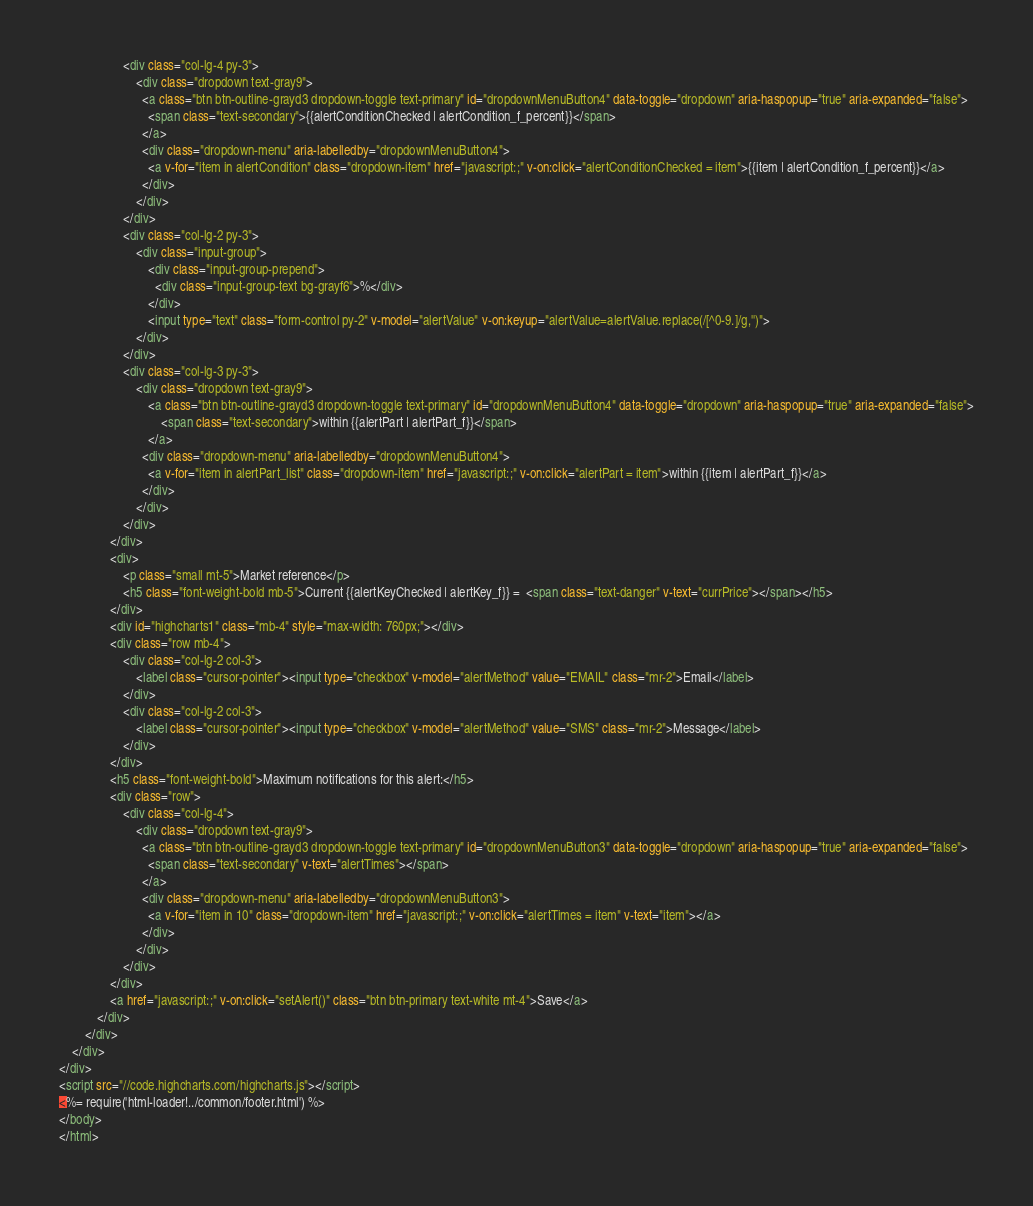Convert code to text. <code><loc_0><loc_0><loc_500><loc_500><_HTML_>					<div class="col-lg-4 py-3">
						<div class="dropdown text-gray9">
						  <a class="btn btn-outline-grayd3 dropdown-toggle text-primary" id="dropdownMenuButton4" data-toggle="dropdown" aria-haspopup="true" aria-expanded="false">
						  	<span class="text-secondary">{{alertConditionChecked | alertCondition_f_percent}}</span>
						  </a>
						  <div class="dropdown-menu" aria-labelledby="dropdownMenuButton4">
						    <a v-for="item in alertCondition" class="dropdown-item" href="javascript:;" v-on:click="alertConditionChecked = item">{{item | alertCondition_f_percent}}</a>
						  </div>
						</div>
					</div>
					<div class="col-lg-2 py-3">
						<div class="input-group">
					        <div class="input-group-prepend">
					          <div class="input-group-text bg-grayf6">%</div>
					        </div>
					        <input type="text" class="form-control py-2" v-model="alertValue" v-on:keyup="alertValue=alertValue.replace(/[^0-9.]/g,'')">
					    </div>
					</div>
					<div class="col-lg-3 py-3">
						<div class="dropdown text-gray9">
							<a class="btn btn-outline-grayd3 dropdown-toggle text-primary" id="dropdownMenuButton4" data-toggle="dropdown" aria-haspopup="true" aria-expanded="false">
						  		<span class="text-secondary">within {{alertPart | alertPart_f}}</span>
						  	</a>
						  <div class="dropdown-menu" aria-labelledby="dropdownMenuButton4">
						    <a v-for="item in alertPart_list" class="dropdown-item" href="javascript:;" v-on:click="alertPart = item">within {{item | alertPart_f}}</a>
						  </div>
						</div>
					</div>
				</div>
				<div>
					<p class="small mt-5">Market reference</p>
					<h5 class="font-weight-bold mb-5">Current {{alertKeyChecked | alertKey_f}} =  <span class="text-danger" v-text="currPrice"></span></h5>
				</div>
				<div id="highcharts1" class="mb-4" style="max-width: 760px;"></div>
				<div class="row mb-4">
					<div class="col-lg-2 col-3">
						<label class="cursor-pointer"><input type="checkbox" v-model="alertMethod" value="EMAIL" class="mr-2">Email</label>
					</div>
					<div class="col-lg-2 col-3">
						<label class="cursor-pointer"><input type="checkbox" v-model="alertMethod" value="SMS" class="mr-2">Message</label>
					</div>
				</div>
				<h5 class="font-weight-bold">Maximum notifications for this alert:</h5>
				<div class="row">
					<div class="col-lg-4">
						<div class="dropdown text-gray9">
						  <a class="btn btn-outline-grayd3 dropdown-toggle text-primary" id="dropdownMenuButton3" data-toggle="dropdown" aria-haspopup="true" aria-expanded="false">
						  	<span class="text-secondary" v-text="alertTimes"></span>
						  </a>
						  <div class="dropdown-menu" aria-labelledby="dropdownMenuButton3">
						    <a v-for="item in 10" class="dropdown-item" href="javascript:;" v-on:click="alertTimes = item" v-text="item"></a>
						  </div>
						</div>
					</div>
				</div>
				<a href="javascript:;" v-on:click="setAlert()" class="btn btn-primary text-white mt-4">Save</a>
			</div>
		</div>
	</div>
</div>
<script src="//code.highcharts.com/highcharts.js"></script>
<%= require('html-loader!../common/footer.html') %>
</body>
</html></code> 